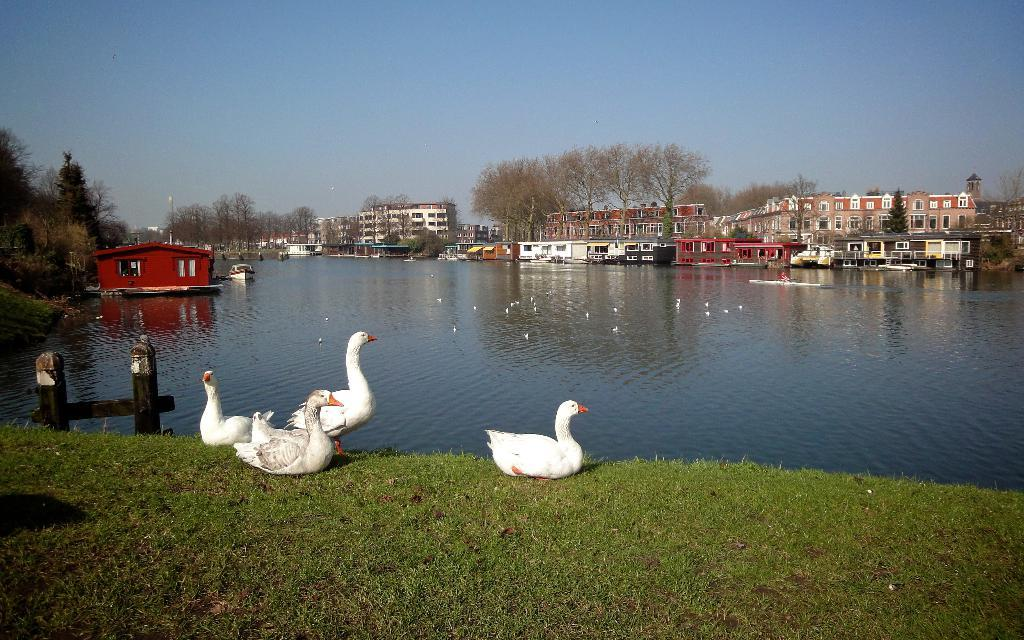What animals are present in the image? There are swans in the image. What colors are the swans? The swans are in white and orange colors. What can be seen in the background of the image? There are buildings and trees visible in the background. What is the primary element in which the swans are situated? Water is present in the image, and the swans are in it. What is the color of the sky in the image? The sky is blue in color. Can you see any fairies flying around the swans in the image? There are no fairies present in the image. 